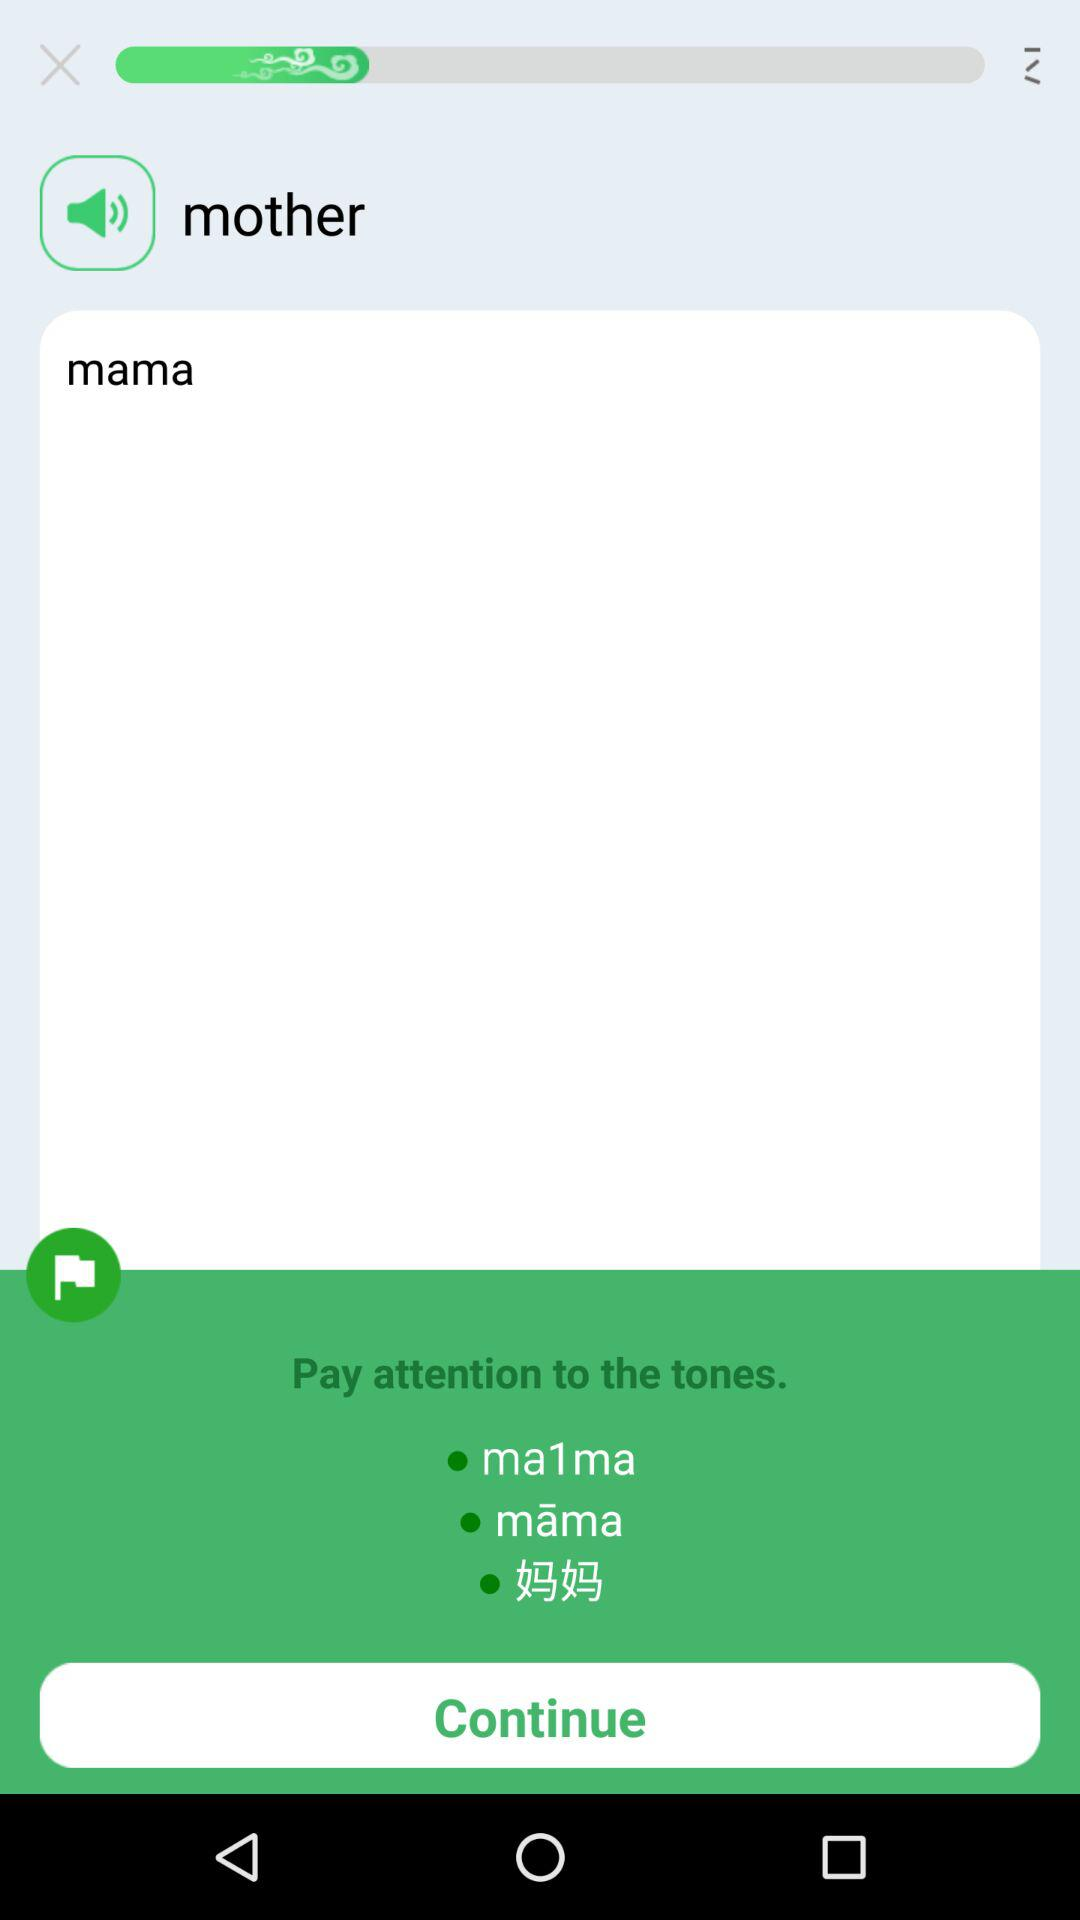Which are the different tones?
When the provided information is insufficient, respond with <no answer>. <no answer> 